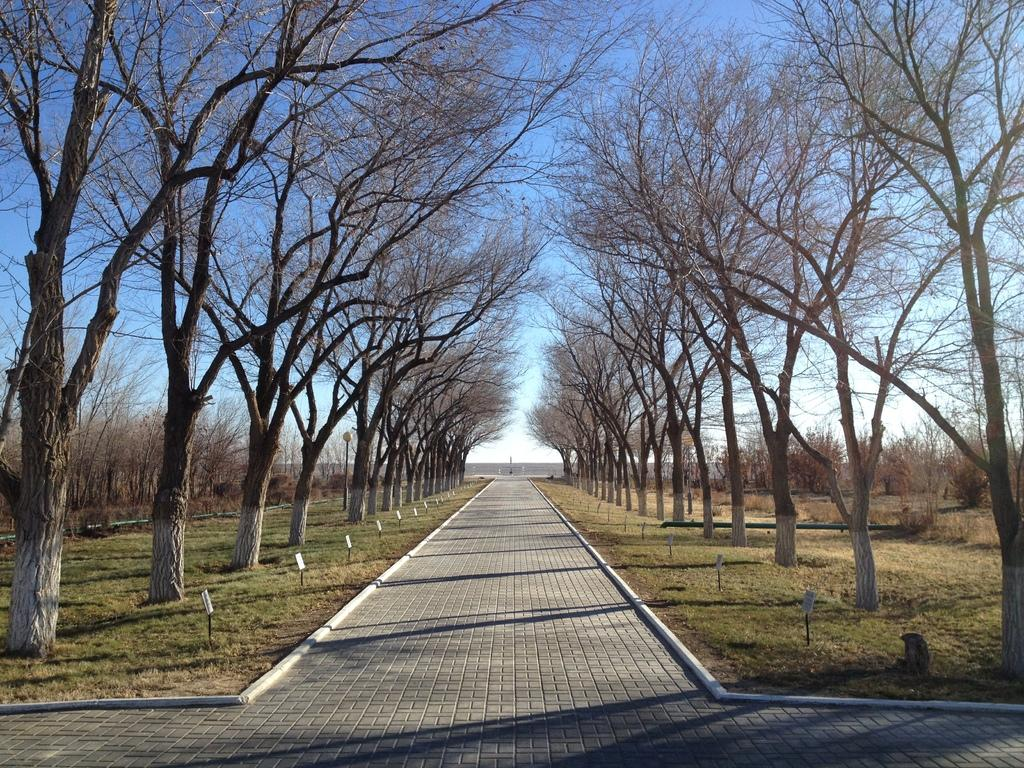What type of surface can be seen in the image? There is a path in the image. What type of vegetation is present at the bottom of the image? Grass is present at the bottom of the image. What can be seen on either side of the path? There are trees to the left and right of the path. What is visible at the top of the image? The sky is visible at the top of the image. What type of beef is being served on the path in the image? There is no beef present in the image; it features a path with grass, trees, and sky. How many mice can be seen running along the path in the image? There are no mice present in the image; it features a path with grass, trees, and sky. 